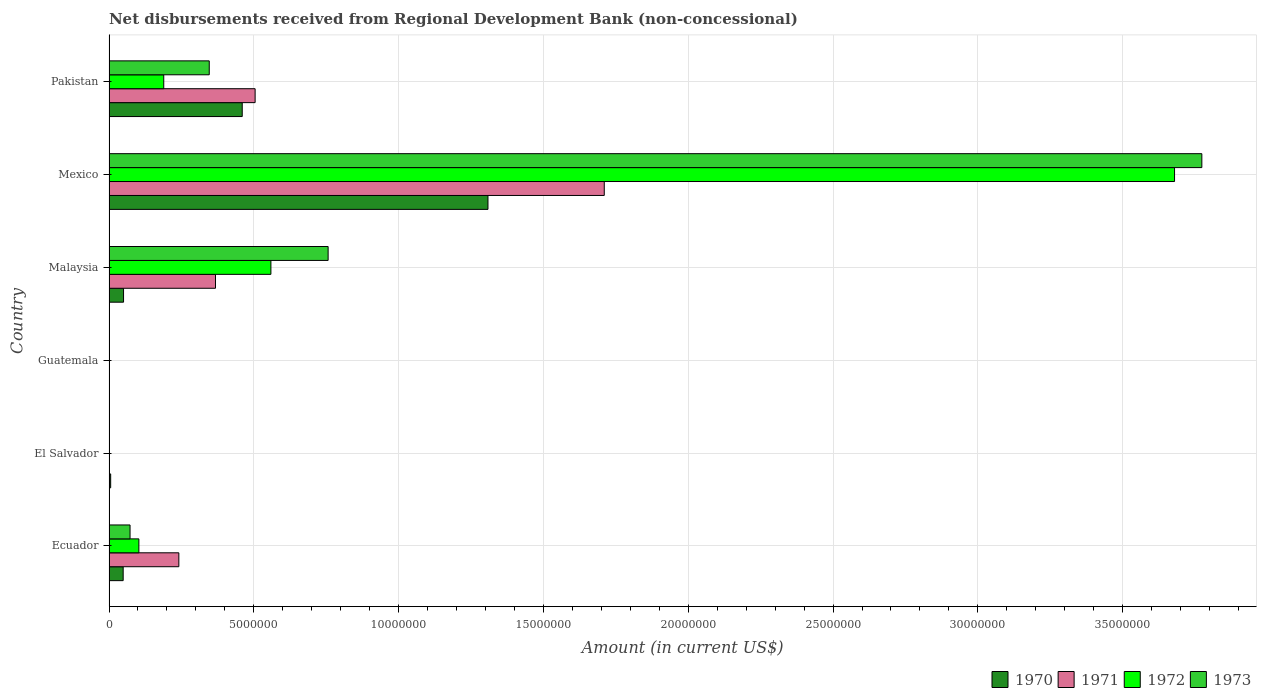How many different coloured bars are there?
Keep it short and to the point. 4. Are the number of bars per tick equal to the number of legend labels?
Your response must be concise. No. Are the number of bars on each tick of the Y-axis equal?
Offer a terse response. No. How many bars are there on the 5th tick from the top?
Provide a short and direct response. 1. What is the label of the 4th group of bars from the top?
Provide a short and direct response. Guatemala. What is the amount of disbursements received from Regional Development Bank in 1972 in Malaysia?
Provide a succinct answer. 5.59e+06. Across all countries, what is the maximum amount of disbursements received from Regional Development Bank in 1973?
Keep it short and to the point. 3.77e+07. What is the total amount of disbursements received from Regional Development Bank in 1970 in the graph?
Your answer should be very brief. 1.87e+07. What is the difference between the amount of disbursements received from Regional Development Bank in 1970 in Ecuador and that in Malaysia?
Your answer should be compact. -1.30e+04. What is the difference between the amount of disbursements received from Regional Development Bank in 1973 in El Salvador and the amount of disbursements received from Regional Development Bank in 1971 in Pakistan?
Your answer should be compact. -5.04e+06. What is the average amount of disbursements received from Regional Development Bank in 1970 per country?
Ensure brevity in your answer.  3.12e+06. What is the difference between the amount of disbursements received from Regional Development Bank in 1971 and amount of disbursements received from Regional Development Bank in 1970 in Malaysia?
Ensure brevity in your answer.  3.18e+06. In how many countries, is the amount of disbursements received from Regional Development Bank in 1972 greater than 11000000 US$?
Give a very brief answer. 1. What is the ratio of the amount of disbursements received from Regional Development Bank in 1973 in Ecuador to that in Pakistan?
Give a very brief answer. 0.21. Is the amount of disbursements received from Regional Development Bank in 1972 in Mexico less than that in Pakistan?
Your response must be concise. No. Is the difference between the amount of disbursements received from Regional Development Bank in 1971 in Ecuador and Mexico greater than the difference between the amount of disbursements received from Regional Development Bank in 1970 in Ecuador and Mexico?
Your answer should be very brief. No. What is the difference between the highest and the second highest amount of disbursements received from Regional Development Bank in 1972?
Ensure brevity in your answer.  3.12e+07. What is the difference between the highest and the lowest amount of disbursements received from Regional Development Bank in 1973?
Offer a very short reply. 3.77e+07. In how many countries, is the amount of disbursements received from Regional Development Bank in 1972 greater than the average amount of disbursements received from Regional Development Bank in 1972 taken over all countries?
Your answer should be compact. 1. Is the sum of the amount of disbursements received from Regional Development Bank in 1971 in Ecuador and Mexico greater than the maximum amount of disbursements received from Regional Development Bank in 1970 across all countries?
Your answer should be compact. Yes. Is it the case that in every country, the sum of the amount of disbursements received from Regional Development Bank in 1972 and amount of disbursements received from Regional Development Bank in 1971 is greater than the sum of amount of disbursements received from Regional Development Bank in 1973 and amount of disbursements received from Regional Development Bank in 1970?
Give a very brief answer. No. Is it the case that in every country, the sum of the amount of disbursements received from Regional Development Bank in 1970 and amount of disbursements received from Regional Development Bank in 1972 is greater than the amount of disbursements received from Regional Development Bank in 1973?
Ensure brevity in your answer.  No. How many bars are there?
Offer a terse response. 17. Are all the bars in the graph horizontal?
Your answer should be compact. Yes. How many countries are there in the graph?
Make the answer very short. 6. What is the difference between two consecutive major ticks on the X-axis?
Your response must be concise. 5.00e+06. Are the values on the major ticks of X-axis written in scientific E-notation?
Provide a short and direct response. No. Does the graph contain any zero values?
Provide a short and direct response. Yes. Where does the legend appear in the graph?
Your response must be concise. Bottom right. How many legend labels are there?
Your response must be concise. 4. What is the title of the graph?
Give a very brief answer. Net disbursements received from Regional Development Bank (non-concessional). What is the Amount (in current US$) of 1970 in Ecuador?
Your answer should be compact. 4.89e+05. What is the Amount (in current US$) in 1971 in Ecuador?
Give a very brief answer. 2.41e+06. What is the Amount (in current US$) of 1972 in Ecuador?
Provide a short and direct response. 1.03e+06. What is the Amount (in current US$) in 1973 in Ecuador?
Ensure brevity in your answer.  7.26e+05. What is the Amount (in current US$) in 1970 in El Salvador?
Your answer should be very brief. 5.70e+04. What is the Amount (in current US$) of 1971 in El Salvador?
Your answer should be very brief. 0. What is the Amount (in current US$) of 1972 in El Salvador?
Provide a short and direct response. 0. What is the Amount (in current US$) of 1970 in Guatemala?
Provide a short and direct response. 0. What is the Amount (in current US$) of 1972 in Guatemala?
Your answer should be very brief. 0. What is the Amount (in current US$) of 1973 in Guatemala?
Your answer should be compact. 0. What is the Amount (in current US$) of 1970 in Malaysia?
Ensure brevity in your answer.  5.02e+05. What is the Amount (in current US$) in 1971 in Malaysia?
Offer a terse response. 3.68e+06. What is the Amount (in current US$) in 1972 in Malaysia?
Offer a very short reply. 5.59e+06. What is the Amount (in current US$) of 1973 in Malaysia?
Provide a succinct answer. 7.57e+06. What is the Amount (in current US$) in 1970 in Mexico?
Make the answer very short. 1.31e+07. What is the Amount (in current US$) in 1971 in Mexico?
Your answer should be very brief. 1.71e+07. What is the Amount (in current US$) in 1972 in Mexico?
Your response must be concise. 3.68e+07. What is the Amount (in current US$) in 1973 in Mexico?
Your answer should be compact. 3.77e+07. What is the Amount (in current US$) in 1970 in Pakistan?
Provide a short and direct response. 4.60e+06. What is the Amount (in current US$) in 1971 in Pakistan?
Your response must be concise. 5.04e+06. What is the Amount (in current US$) of 1972 in Pakistan?
Keep it short and to the point. 1.89e+06. What is the Amount (in current US$) in 1973 in Pakistan?
Ensure brevity in your answer.  3.46e+06. Across all countries, what is the maximum Amount (in current US$) in 1970?
Ensure brevity in your answer.  1.31e+07. Across all countries, what is the maximum Amount (in current US$) of 1971?
Give a very brief answer. 1.71e+07. Across all countries, what is the maximum Amount (in current US$) in 1972?
Your response must be concise. 3.68e+07. Across all countries, what is the maximum Amount (in current US$) of 1973?
Make the answer very short. 3.77e+07. Across all countries, what is the minimum Amount (in current US$) in 1971?
Ensure brevity in your answer.  0. Across all countries, what is the minimum Amount (in current US$) of 1973?
Provide a succinct answer. 0. What is the total Amount (in current US$) of 1970 in the graph?
Keep it short and to the point. 1.87e+07. What is the total Amount (in current US$) in 1971 in the graph?
Give a very brief answer. 2.82e+07. What is the total Amount (in current US$) in 1972 in the graph?
Ensure brevity in your answer.  4.53e+07. What is the total Amount (in current US$) of 1973 in the graph?
Offer a very short reply. 4.95e+07. What is the difference between the Amount (in current US$) of 1970 in Ecuador and that in El Salvador?
Provide a succinct answer. 4.32e+05. What is the difference between the Amount (in current US$) in 1970 in Ecuador and that in Malaysia?
Provide a short and direct response. -1.30e+04. What is the difference between the Amount (in current US$) in 1971 in Ecuador and that in Malaysia?
Offer a very short reply. -1.27e+06. What is the difference between the Amount (in current US$) in 1972 in Ecuador and that in Malaysia?
Your answer should be compact. -4.56e+06. What is the difference between the Amount (in current US$) in 1973 in Ecuador and that in Malaysia?
Offer a very short reply. -6.84e+06. What is the difference between the Amount (in current US$) in 1970 in Ecuador and that in Mexico?
Offer a very short reply. -1.26e+07. What is the difference between the Amount (in current US$) in 1971 in Ecuador and that in Mexico?
Your answer should be compact. -1.47e+07. What is the difference between the Amount (in current US$) of 1972 in Ecuador and that in Mexico?
Your response must be concise. -3.58e+07. What is the difference between the Amount (in current US$) in 1973 in Ecuador and that in Mexico?
Your answer should be compact. -3.70e+07. What is the difference between the Amount (in current US$) of 1970 in Ecuador and that in Pakistan?
Your answer should be compact. -4.11e+06. What is the difference between the Amount (in current US$) of 1971 in Ecuador and that in Pakistan?
Offer a terse response. -2.63e+06. What is the difference between the Amount (in current US$) of 1972 in Ecuador and that in Pakistan?
Ensure brevity in your answer.  -8.59e+05. What is the difference between the Amount (in current US$) of 1973 in Ecuador and that in Pakistan?
Ensure brevity in your answer.  -2.74e+06. What is the difference between the Amount (in current US$) of 1970 in El Salvador and that in Malaysia?
Your response must be concise. -4.45e+05. What is the difference between the Amount (in current US$) in 1970 in El Salvador and that in Mexico?
Provide a short and direct response. -1.30e+07. What is the difference between the Amount (in current US$) in 1970 in El Salvador and that in Pakistan?
Provide a short and direct response. -4.54e+06. What is the difference between the Amount (in current US$) of 1970 in Malaysia and that in Mexico?
Make the answer very short. -1.26e+07. What is the difference between the Amount (in current US$) of 1971 in Malaysia and that in Mexico?
Make the answer very short. -1.34e+07. What is the difference between the Amount (in current US$) in 1972 in Malaysia and that in Mexico?
Keep it short and to the point. -3.12e+07. What is the difference between the Amount (in current US$) of 1973 in Malaysia and that in Mexico?
Keep it short and to the point. -3.02e+07. What is the difference between the Amount (in current US$) of 1970 in Malaysia and that in Pakistan?
Keep it short and to the point. -4.10e+06. What is the difference between the Amount (in current US$) in 1971 in Malaysia and that in Pakistan?
Make the answer very short. -1.37e+06. What is the difference between the Amount (in current US$) in 1972 in Malaysia and that in Pakistan?
Offer a terse response. 3.70e+06. What is the difference between the Amount (in current US$) of 1973 in Malaysia and that in Pakistan?
Make the answer very short. 4.10e+06. What is the difference between the Amount (in current US$) in 1970 in Mexico and that in Pakistan?
Offer a terse response. 8.48e+06. What is the difference between the Amount (in current US$) of 1971 in Mexico and that in Pakistan?
Keep it short and to the point. 1.21e+07. What is the difference between the Amount (in current US$) of 1972 in Mexico and that in Pakistan?
Make the answer very short. 3.49e+07. What is the difference between the Amount (in current US$) in 1973 in Mexico and that in Pakistan?
Your answer should be compact. 3.43e+07. What is the difference between the Amount (in current US$) of 1970 in Ecuador and the Amount (in current US$) of 1971 in Malaysia?
Your answer should be compact. -3.19e+06. What is the difference between the Amount (in current US$) in 1970 in Ecuador and the Amount (in current US$) in 1972 in Malaysia?
Offer a terse response. -5.10e+06. What is the difference between the Amount (in current US$) of 1970 in Ecuador and the Amount (in current US$) of 1973 in Malaysia?
Provide a short and direct response. -7.08e+06. What is the difference between the Amount (in current US$) of 1971 in Ecuador and the Amount (in current US$) of 1972 in Malaysia?
Make the answer very short. -3.18e+06. What is the difference between the Amount (in current US$) in 1971 in Ecuador and the Amount (in current US$) in 1973 in Malaysia?
Offer a very short reply. -5.16e+06. What is the difference between the Amount (in current US$) in 1972 in Ecuador and the Amount (in current US$) in 1973 in Malaysia?
Offer a terse response. -6.54e+06. What is the difference between the Amount (in current US$) of 1970 in Ecuador and the Amount (in current US$) of 1971 in Mexico?
Provide a short and direct response. -1.66e+07. What is the difference between the Amount (in current US$) in 1970 in Ecuador and the Amount (in current US$) in 1972 in Mexico?
Offer a terse response. -3.63e+07. What is the difference between the Amount (in current US$) in 1970 in Ecuador and the Amount (in current US$) in 1973 in Mexico?
Keep it short and to the point. -3.72e+07. What is the difference between the Amount (in current US$) of 1971 in Ecuador and the Amount (in current US$) of 1972 in Mexico?
Give a very brief answer. -3.44e+07. What is the difference between the Amount (in current US$) of 1971 in Ecuador and the Amount (in current US$) of 1973 in Mexico?
Your response must be concise. -3.53e+07. What is the difference between the Amount (in current US$) of 1972 in Ecuador and the Amount (in current US$) of 1973 in Mexico?
Your response must be concise. -3.67e+07. What is the difference between the Amount (in current US$) of 1970 in Ecuador and the Amount (in current US$) of 1971 in Pakistan?
Ensure brevity in your answer.  -4.56e+06. What is the difference between the Amount (in current US$) of 1970 in Ecuador and the Amount (in current US$) of 1972 in Pakistan?
Your answer should be very brief. -1.40e+06. What is the difference between the Amount (in current US$) of 1970 in Ecuador and the Amount (in current US$) of 1973 in Pakistan?
Make the answer very short. -2.97e+06. What is the difference between the Amount (in current US$) in 1971 in Ecuador and the Amount (in current US$) in 1972 in Pakistan?
Offer a very short reply. 5.21e+05. What is the difference between the Amount (in current US$) of 1971 in Ecuador and the Amount (in current US$) of 1973 in Pakistan?
Give a very brief answer. -1.05e+06. What is the difference between the Amount (in current US$) of 1972 in Ecuador and the Amount (in current US$) of 1973 in Pakistan?
Offer a very short reply. -2.43e+06. What is the difference between the Amount (in current US$) of 1970 in El Salvador and the Amount (in current US$) of 1971 in Malaysia?
Your response must be concise. -3.62e+06. What is the difference between the Amount (in current US$) of 1970 in El Salvador and the Amount (in current US$) of 1972 in Malaysia?
Give a very brief answer. -5.53e+06. What is the difference between the Amount (in current US$) in 1970 in El Salvador and the Amount (in current US$) in 1973 in Malaysia?
Provide a short and direct response. -7.51e+06. What is the difference between the Amount (in current US$) of 1970 in El Salvador and the Amount (in current US$) of 1971 in Mexico?
Your response must be concise. -1.70e+07. What is the difference between the Amount (in current US$) of 1970 in El Salvador and the Amount (in current US$) of 1972 in Mexico?
Offer a very short reply. -3.67e+07. What is the difference between the Amount (in current US$) in 1970 in El Salvador and the Amount (in current US$) in 1973 in Mexico?
Your answer should be very brief. -3.77e+07. What is the difference between the Amount (in current US$) in 1970 in El Salvador and the Amount (in current US$) in 1971 in Pakistan?
Your response must be concise. -4.99e+06. What is the difference between the Amount (in current US$) of 1970 in El Salvador and the Amount (in current US$) of 1972 in Pakistan?
Give a very brief answer. -1.83e+06. What is the difference between the Amount (in current US$) in 1970 in El Salvador and the Amount (in current US$) in 1973 in Pakistan?
Provide a succinct answer. -3.40e+06. What is the difference between the Amount (in current US$) in 1970 in Malaysia and the Amount (in current US$) in 1971 in Mexico?
Your response must be concise. -1.66e+07. What is the difference between the Amount (in current US$) of 1970 in Malaysia and the Amount (in current US$) of 1972 in Mexico?
Give a very brief answer. -3.63e+07. What is the difference between the Amount (in current US$) of 1970 in Malaysia and the Amount (in current US$) of 1973 in Mexico?
Make the answer very short. -3.72e+07. What is the difference between the Amount (in current US$) in 1971 in Malaysia and the Amount (in current US$) in 1972 in Mexico?
Provide a short and direct response. -3.31e+07. What is the difference between the Amount (in current US$) of 1971 in Malaysia and the Amount (in current US$) of 1973 in Mexico?
Your answer should be compact. -3.41e+07. What is the difference between the Amount (in current US$) of 1972 in Malaysia and the Amount (in current US$) of 1973 in Mexico?
Your answer should be very brief. -3.21e+07. What is the difference between the Amount (in current US$) of 1970 in Malaysia and the Amount (in current US$) of 1971 in Pakistan?
Give a very brief answer. -4.54e+06. What is the difference between the Amount (in current US$) of 1970 in Malaysia and the Amount (in current US$) of 1972 in Pakistan?
Keep it short and to the point. -1.39e+06. What is the difference between the Amount (in current US$) in 1970 in Malaysia and the Amount (in current US$) in 1973 in Pakistan?
Your response must be concise. -2.96e+06. What is the difference between the Amount (in current US$) in 1971 in Malaysia and the Amount (in current US$) in 1972 in Pakistan?
Give a very brief answer. 1.79e+06. What is the difference between the Amount (in current US$) in 1971 in Malaysia and the Amount (in current US$) in 1973 in Pakistan?
Your answer should be very brief. 2.16e+05. What is the difference between the Amount (in current US$) in 1972 in Malaysia and the Amount (in current US$) in 1973 in Pakistan?
Make the answer very short. 2.13e+06. What is the difference between the Amount (in current US$) in 1970 in Mexico and the Amount (in current US$) in 1971 in Pakistan?
Your response must be concise. 8.04e+06. What is the difference between the Amount (in current US$) in 1970 in Mexico and the Amount (in current US$) in 1972 in Pakistan?
Give a very brief answer. 1.12e+07. What is the difference between the Amount (in current US$) of 1970 in Mexico and the Amount (in current US$) of 1973 in Pakistan?
Your answer should be compact. 9.62e+06. What is the difference between the Amount (in current US$) of 1971 in Mexico and the Amount (in current US$) of 1972 in Pakistan?
Your answer should be very brief. 1.52e+07. What is the difference between the Amount (in current US$) in 1971 in Mexico and the Amount (in current US$) in 1973 in Pakistan?
Provide a succinct answer. 1.36e+07. What is the difference between the Amount (in current US$) in 1972 in Mexico and the Amount (in current US$) in 1973 in Pakistan?
Provide a short and direct response. 3.33e+07. What is the average Amount (in current US$) of 1970 per country?
Your response must be concise. 3.12e+06. What is the average Amount (in current US$) of 1971 per country?
Keep it short and to the point. 4.71e+06. What is the average Amount (in current US$) of 1972 per country?
Offer a very short reply. 7.55e+06. What is the average Amount (in current US$) in 1973 per country?
Offer a very short reply. 8.25e+06. What is the difference between the Amount (in current US$) in 1970 and Amount (in current US$) in 1971 in Ecuador?
Offer a terse response. -1.92e+06. What is the difference between the Amount (in current US$) of 1970 and Amount (in current US$) of 1972 in Ecuador?
Provide a succinct answer. -5.42e+05. What is the difference between the Amount (in current US$) of 1970 and Amount (in current US$) of 1973 in Ecuador?
Your answer should be very brief. -2.37e+05. What is the difference between the Amount (in current US$) of 1971 and Amount (in current US$) of 1972 in Ecuador?
Provide a succinct answer. 1.38e+06. What is the difference between the Amount (in current US$) of 1971 and Amount (in current US$) of 1973 in Ecuador?
Your answer should be very brief. 1.68e+06. What is the difference between the Amount (in current US$) of 1972 and Amount (in current US$) of 1973 in Ecuador?
Your response must be concise. 3.05e+05. What is the difference between the Amount (in current US$) in 1970 and Amount (in current US$) in 1971 in Malaysia?
Make the answer very short. -3.18e+06. What is the difference between the Amount (in current US$) in 1970 and Amount (in current US$) in 1972 in Malaysia?
Offer a terse response. -5.09e+06. What is the difference between the Amount (in current US$) of 1970 and Amount (in current US$) of 1973 in Malaysia?
Your answer should be very brief. -7.06e+06. What is the difference between the Amount (in current US$) of 1971 and Amount (in current US$) of 1972 in Malaysia?
Make the answer very short. -1.91e+06. What is the difference between the Amount (in current US$) in 1971 and Amount (in current US$) in 1973 in Malaysia?
Your answer should be compact. -3.89e+06. What is the difference between the Amount (in current US$) in 1972 and Amount (in current US$) in 1973 in Malaysia?
Provide a succinct answer. -1.98e+06. What is the difference between the Amount (in current US$) in 1970 and Amount (in current US$) in 1971 in Mexico?
Give a very brief answer. -4.02e+06. What is the difference between the Amount (in current US$) in 1970 and Amount (in current US$) in 1972 in Mexico?
Your response must be concise. -2.37e+07. What is the difference between the Amount (in current US$) of 1970 and Amount (in current US$) of 1973 in Mexico?
Your answer should be compact. -2.46e+07. What is the difference between the Amount (in current US$) in 1971 and Amount (in current US$) in 1972 in Mexico?
Keep it short and to the point. -1.97e+07. What is the difference between the Amount (in current US$) in 1971 and Amount (in current US$) in 1973 in Mexico?
Your answer should be very brief. -2.06e+07. What is the difference between the Amount (in current US$) of 1972 and Amount (in current US$) of 1973 in Mexico?
Keep it short and to the point. -9.43e+05. What is the difference between the Amount (in current US$) in 1970 and Amount (in current US$) in 1971 in Pakistan?
Ensure brevity in your answer.  -4.45e+05. What is the difference between the Amount (in current US$) of 1970 and Amount (in current US$) of 1972 in Pakistan?
Your answer should be very brief. 2.71e+06. What is the difference between the Amount (in current US$) of 1970 and Amount (in current US$) of 1973 in Pakistan?
Give a very brief answer. 1.14e+06. What is the difference between the Amount (in current US$) in 1971 and Amount (in current US$) in 1972 in Pakistan?
Provide a short and direct response. 3.16e+06. What is the difference between the Amount (in current US$) of 1971 and Amount (in current US$) of 1973 in Pakistan?
Your answer should be compact. 1.58e+06. What is the difference between the Amount (in current US$) in 1972 and Amount (in current US$) in 1973 in Pakistan?
Ensure brevity in your answer.  -1.57e+06. What is the ratio of the Amount (in current US$) in 1970 in Ecuador to that in El Salvador?
Your answer should be very brief. 8.58. What is the ratio of the Amount (in current US$) in 1970 in Ecuador to that in Malaysia?
Make the answer very short. 0.97. What is the ratio of the Amount (in current US$) of 1971 in Ecuador to that in Malaysia?
Make the answer very short. 0.66. What is the ratio of the Amount (in current US$) in 1972 in Ecuador to that in Malaysia?
Ensure brevity in your answer.  0.18. What is the ratio of the Amount (in current US$) of 1973 in Ecuador to that in Malaysia?
Keep it short and to the point. 0.1. What is the ratio of the Amount (in current US$) of 1970 in Ecuador to that in Mexico?
Ensure brevity in your answer.  0.04. What is the ratio of the Amount (in current US$) in 1971 in Ecuador to that in Mexico?
Give a very brief answer. 0.14. What is the ratio of the Amount (in current US$) in 1972 in Ecuador to that in Mexico?
Your answer should be very brief. 0.03. What is the ratio of the Amount (in current US$) of 1973 in Ecuador to that in Mexico?
Offer a terse response. 0.02. What is the ratio of the Amount (in current US$) in 1970 in Ecuador to that in Pakistan?
Your response must be concise. 0.11. What is the ratio of the Amount (in current US$) in 1971 in Ecuador to that in Pakistan?
Make the answer very short. 0.48. What is the ratio of the Amount (in current US$) in 1972 in Ecuador to that in Pakistan?
Your answer should be compact. 0.55. What is the ratio of the Amount (in current US$) of 1973 in Ecuador to that in Pakistan?
Ensure brevity in your answer.  0.21. What is the ratio of the Amount (in current US$) of 1970 in El Salvador to that in Malaysia?
Your answer should be very brief. 0.11. What is the ratio of the Amount (in current US$) of 1970 in El Salvador to that in Mexico?
Your answer should be very brief. 0. What is the ratio of the Amount (in current US$) in 1970 in El Salvador to that in Pakistan?
Give a very brief answer. 0.01. What is the ratio of the Amount (in current US$) in 1970 in Malaysia to that in Mexico?
Provide a succinct answer. 0.04. What is the ratio of the Amount (in current US$) of 1971 in Malaysia to that in Mexico?
Give a very brief answer. 0.21. What is the ratio of the Amount (in current US$) in 1972 in Malaysia to that in Mexico?
Your response must be concise. 0.15. What is the ratio of the Amount (in current US$) of 1973 in Malaysia to that in Mexico?
Make the answer very short. 0.2. What is the ratio of the Amount (in current US$) of 1970 in Malaysia to that in Pakistan?
Your response must be concise. 0.11. What is the ratio of the Amount (in current US$) of 1971 in Malaysia to that in Pakistan?
Ensure brevity in your answer.  0.73. What is the ratio of the Amount (in current US$) in 1972 in Malaysia to that in Pakistan?
Give a very brief answer. 2.96. What is the ratio of the Amount (in current US$) of 1973 in Malaysia to that in Pakistan?
Your response must be concise. 2.19. What is the ratio of the Amount (in current US$) in 1970 in Mexico to that in Pakistan?
Your answer should be compact. 2.84. What is the ratio of the Amount (in current US$) in 1971 in Mexico to that in Pakistan?
Offer a very short reply. 3.39. What is the ratio of the Amount (in current US$) of 1972 in Mexico to that in Pakistan?
Your answer should be compact. 19.47. What is the ratio of the Amount (in current US$) of 1973 in Mexico to that in Pakistan?
Give a very brief answer. 10.9. What is the difference between the highest and the second highest Amount (in current US$) in 1970?
Your answer should be very brief. 8.48e+06. What is the difference between the highest and the second highest Amount (in current US$) of 1971?
Give a very brief answer. 1.21e+07. What is the difference between the highest and the second highest Amount (in current US$) of 1972?
Your answer should be compact. 3.12e+07. What is the difference between the highest and the second highest Amount (in current US$) of 1973?
Offer a terse response. 3.02e+07. What is the difference between the highest and the lowest Amount (in current US$) in 1970?
Provide a short and direct response. 1.31e+07. What is the difference between the highest and the lowest Amount (in current US$) in 1971?
Keep it short and to the point. 1.71e+07. What is the difference between the highest and the lowest Amount (in current US$) in 1972?
Your answer should be very brief. 3.68e+07. What is the difference between the highest and the lowest Amount (in current US$) in 1973?
Give a very brief answer. 3.77e+07. 